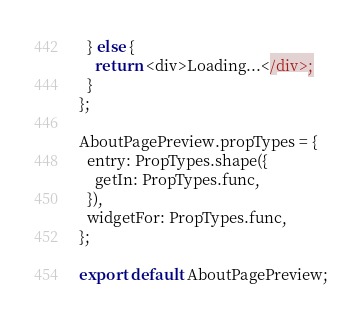<code> <loc_0><loc_0><loc_500><loc_500><_JavaScript_>  } else {
    return <div>Loading...</div>;
  }
};

AboutPagePreview.propTypes = {
  entry: PropTypes.shape({
    getIn: PropTypes.func,
  }),
  widgetFor: PropTypes.func,
};

export default AboutPagePreview;
</code> 